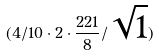<formula> <loc_0><loc_0><loc_500><loc_500>( 4 / 1 0 \cdot 2 \cdot \frac { 2 2 1 } { 8 } / \sqrt { 1 } )</formula> 